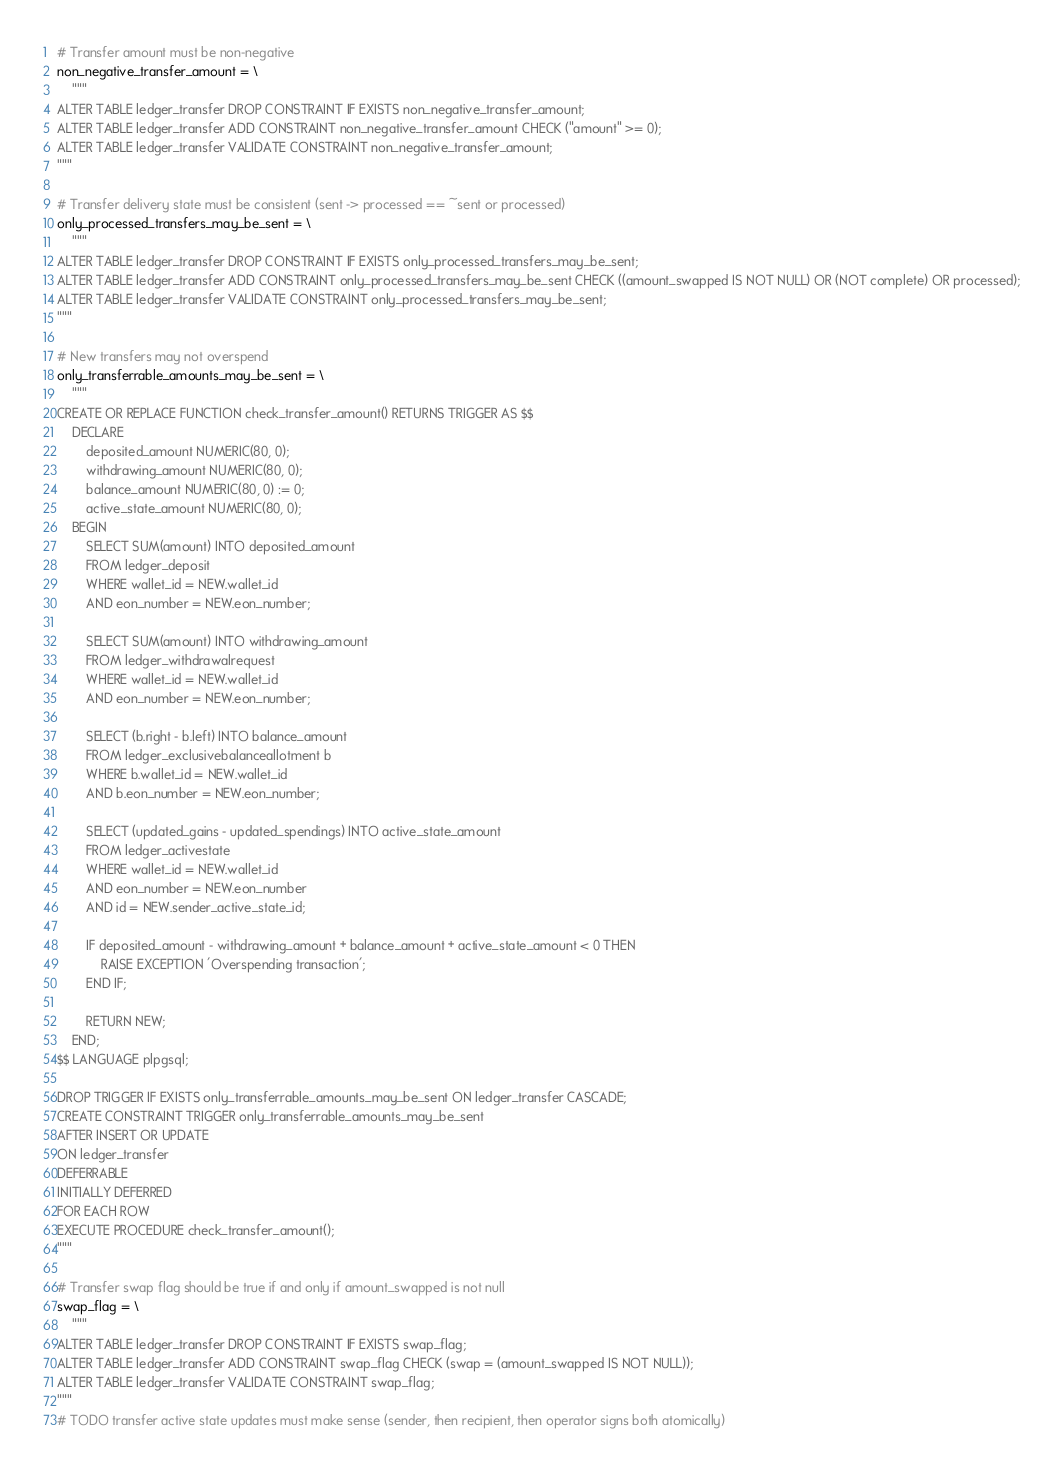<code> <loc_0><loc_0><loc_500><loc_500><_Python_># Transfer amount must be non-negative
non_negative_transfer_amount = \
    """
ALTER TABLE ledger_transfer DROP CONSTRAINT IF EXISTS non_negative_transfer_amount;
ALTER TABLE ledger_transfer ADD CONSTRAINT non_negative_transfer_amount CHECK ("amount" >= 0);
ALTER TABLE ledger_transfer VALIDATE CONSTRAINT non_negative_transfer_amount;
"""

# Transfer delivery state must be consistent (sent -> processed == ~sent or processed)
only_processed_transfers_may_be_sent = \
    """
ALTER TABLE ledger_transfer DROP CONSTRAINT IF EXISTS only_processed_transfers_may_be_sent;
ALTER TABLE ledger_transfer ADD CONSTRAINT only_processed_transfers_may_be_sent CHECK ((amount_swapped IS NOT NULL) OR (NOT complete) OR processed);
ALTER TABLE ledger_transfer VALIDATE CONSTRAINT only_processed_transfers_may_be_sent;
"""

# New transfers may not overspend
only_transferrable_amounts_may_be_sent = \
    """
CREATE OR REPLACE FUNCTION check_transfer_amount() RETURNS TRIGGER AS $$
    DECLARE
        deposited_amount NUMERIC(80, 0);
        withdrawing_amount NUMERIC(80, 0);
        balance_amount NUMERIC(80, 0) := 0;
        active_state_amount NUMERIC(80, 0);
    BEGIN
        SELECT SUM(amount) INTO deposited_amount
        FROM ledger_deposit
        WHERE wallet_id = NEW.wallet_id
        AND eon_number = NEW.eon_number;
        
        SELECT SUM(amount) INTO withdrawing_amount
        FROM ledger_withdrawalrequest
        WHERE wallet_id = NEW.wallet_id
        AND eon_number = NEW.eon_number;
        
        SELECT (b.right - b.left) INTO balance_amount
        FROM ledger_exclusivebalanceallotment b
        WHERE b.wallet_id = NEW.wallet_id
        AND b.eon_number = NEW.eon_number;
        
        SELECT (updated_gains - updated_spendings) INTO active_state_amount
        FROM ledger_activestate
        WHERE wallet_id = NEW.wallet_id
        AND eon_number = NEW.eon_number
        AND id = NEW.sender_active_state_id;
        
        IF deposited_amount - withdrawing_amount + balance_amount + active_state_amount < 0 THEN
            RAISE EXCEPTION 'Overspending transaction';
        END IF;
        
        RETURN NEW;
    END;
$$ LANGUAGE plpgsql;

DROP TRIGGER IF EXISTS only_transferrable_amounts_may_be_sent ON ledger_transfer CASCADE;
CREATE CONSTRAINT TRIGGER only_transferrable_amounts_may_be_sent
AFTER INSERT OR UPDATE
ON ledger_transfer
DEFERRABLE
INITIALLY DEFERRED
FOR EACH ROW
EXECUTE PROCEDURE check_transfer_amount();
"""

# Transfer swap flag should be true if and only if amount_swapped is not null
swap_flag = \
    """
ALTER TABLE ledger_transfer DROP CONSTRAINT IF EXISTS swap_flag;
ALTER TABLE ledger_transfer ADD CONSTRAINT swap_flag CHECK (swap = (amount_swapped IS NOT NULL));
ALTER TABLE ledger_transfer VALIDATE CONSTRAINT swap_flag;
"""
# TODO transfer active state updates must make sense (sender, then recipient, then operator signs both atomically)
</code> 